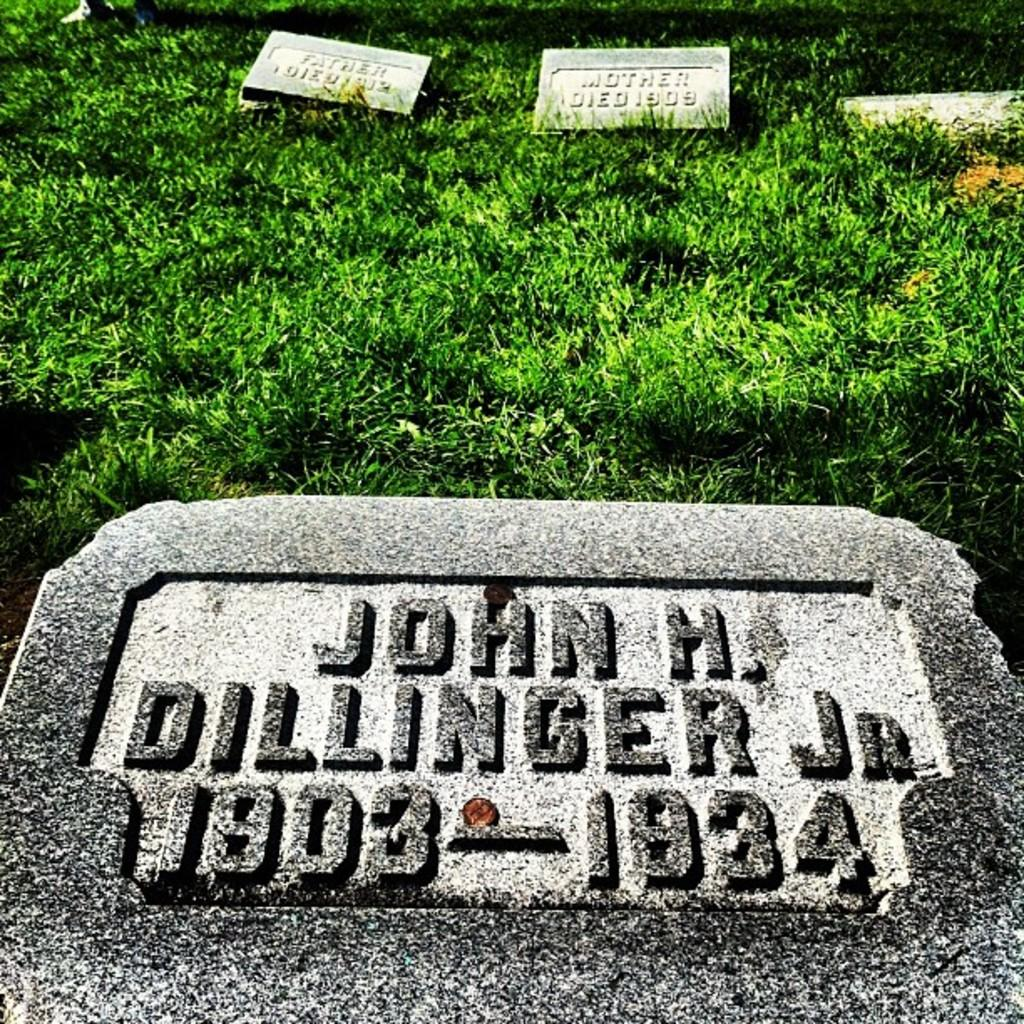What type of objects can be seen in the image? There are memorial stones in the image. Where are the memorial stones located? The memorial stones are on the grass. What advertisement is being displayed on the memorial stones in the image? There is no advertisement present on the memorial stones in the image. What does the dad think about the memorial stones in the image? There is no information about a dad or their opinion in the image. 